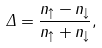<formula> <loc_0><loc_0><loc_500><loc_500>\Delta = \frac { n _ { \uparrow } - n _ { \downarrow } } { n _ { \uparrow } + n _ { \downarrow } } ,</formula> 